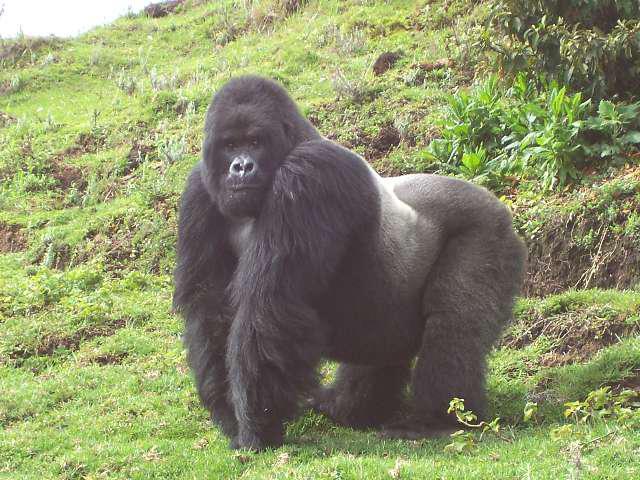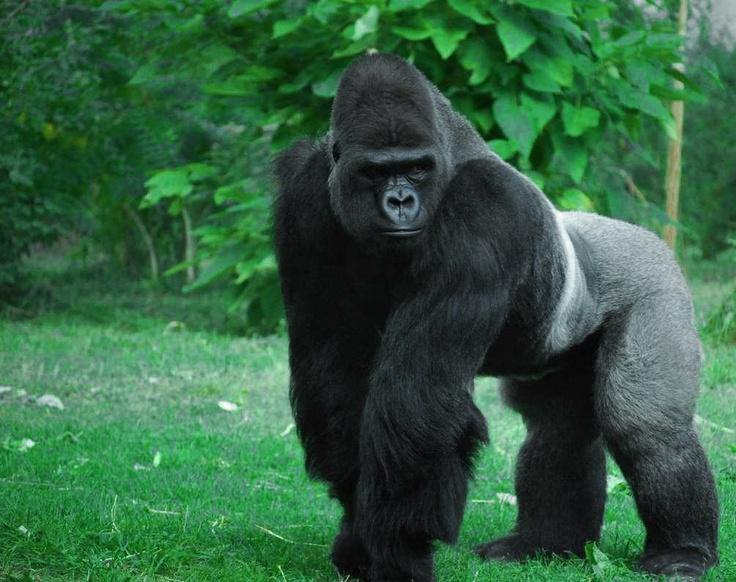The first image is the image on the left, the second image is the image on the right. Evaluate the accuracy of this statement regarding the images: "There is a gorilla holding another gorilla from the back in one of the images.". Is it true? Answer yes or no. No. The first image is the image on the left, the second image is the image on the right. Evaluate the accuracy of this statement regarding the images: "At least one image contains a single adult male gorilla, who is walking in a bent over pose and eyeing the camera.". Is it true? Answer yes or no. Yes. The first image is the image on the left, the second image is the image on the right. Assess this claim about the two images: "The left image contains exactly two gorillas.". Correct or not? Answer yes or no. No. The first image is the image on the left, the second image is the image on the right. Analyze the images presented: Is the assertion "There are exactly three animals outside." valid? Answer yes or no. No. 